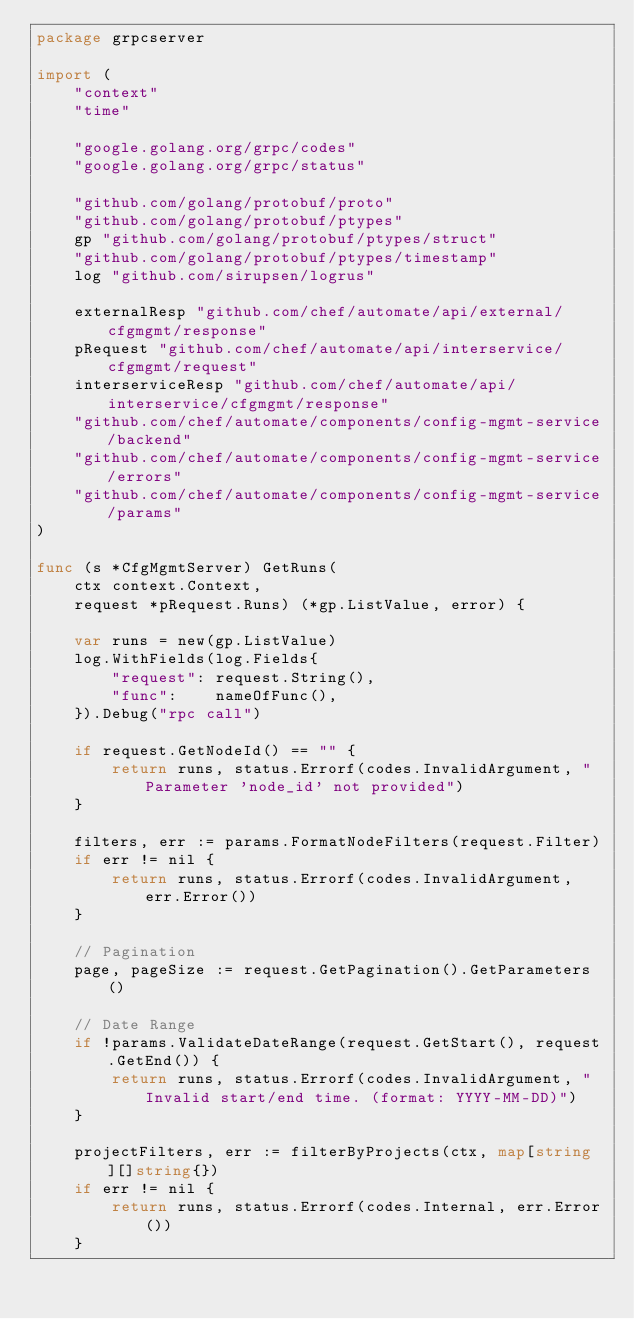<code> <loc_0><loc_0><loc_500><loc_500><_Go_>package grpcserver

import (
	"context"
	"time"

	"google.golang.org/grpc/codes"
	"google.golang.org/grpc/status"

	"github.com/golang/protobuf/proto"
	"github.com/golang/protobuf/ptypes"
	gp "github.com/golang/protobuf/ptypes/struct"
	"github.com/golang/protobuf/ptypes/timestamp"
	log "github.com/sirupsen/logrus"

	externalResp "github.com/chef/automate/api/external/cfgmgmt/response"
	pRequest "github.com/chef/automate/api/interservice/cfgmgmt/request"
	interserviceResp "github.com/chef/automate/api/interservice/cfgmgmt/response"
	"github.com/chef/automate/components/config-mgmt-service/backend"
	"github.com/chef/automate/components/config-mgmt-service/errors"
	"github.com/chef/automate/components/config-mgmt-service/params"
)

func (s *CfgMgmtServer) GetRuns(
	ctx context.Context,
	request *pRequest.Runs) (*gp.ListValue, error) {

	var runs = new(gp.ListValue)
	log.WithFields(log.Fields{
		"request": request.String(),
		"func":    nameOfFunc(),
	}).Debug("rpc call")

	if request.GetNodeId() == "" {
		return runs, status.Errorf(codes.InvalidArgument, "Parameter 'node_id' not provided")
	}

	filters, err := params.FormatNodeFilters(request.Filter)
	if err != nil {
		return runs, status.Errorf(codes.InvalidArgument, err.Error())
	}

	// Pagination
	page, pageSize := request.GetPagination().GetParameters()

	// Date Range
	if !params.ValidateDateRange(request.GetStart(), request.GetEnd()) {
		return runs, status.Errorf(codes.InvalidArgument, "Invalid start/end time. (format: YYYY-MM-DD)")
	}

	projectFilters, err := filterByProjects(ctx, map[string][]string{})
	if err != nil {
		return runs, status.Errorf(codes.Internal, err.Error())
	}
</code> 